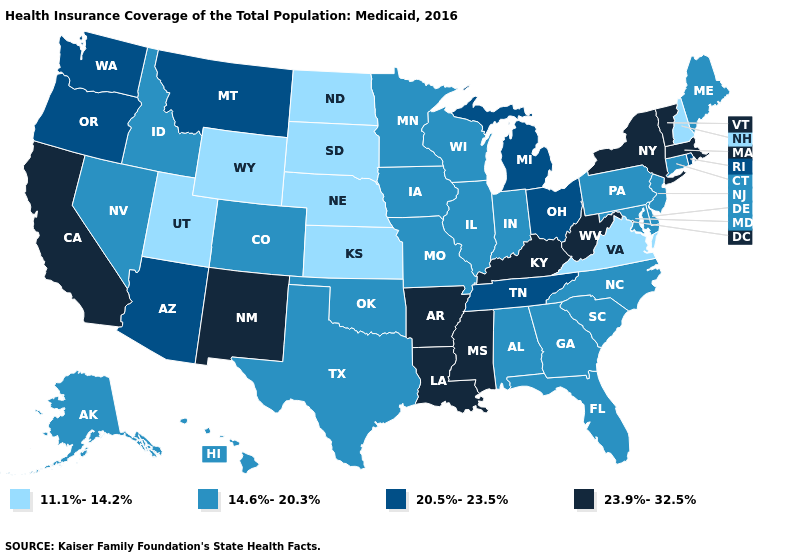What is the value of Utah?
Answer briefly. 11.1%-14.2%. What is the highest value in states that border Tennessee?
Write a very short answer. 23.9%-32.5%. Does Wisconsin have the lowest value in the USA?
Short answer required. No. How many symbols are there in the legend?
Quick response, please. 4. Which states have the highest value in the USA?
Short answer required. Arkansas, California, Kentucky, Louisiana, Massachusetts, Mississippi, New Mexico, New York, Vermont, West Virginia. Among the states that border Ohio , does Pennsylvania have the highest value?
Answer briefly. No. Name the states that have a value in the range 11.1%-14.2%?
Quick response, please. Kansas, Nebraska, New Hampshire, North Dakota, South Dakota, Utah, Virginia, Wyoming. Which states have the lowest value in the MidWest?
Give a very brief answer. Kansas, Nebraska, North Dakota, South Dakota. Name the states that have a value in the range 14.6%-20.3%?
Concise answer only. Alabama, Alaska, Colorado, Connecticut, Delaware, Florida, Georgia, Hawaii, Idaho, Illinois, Indiana, Iowa, Maine, Maryland, Minnesota, Missouri, Nevada, New Jersey, North Carolina, Oklahoma, Pennsylvania, South Carolina, Texas, Wisconsin. Does Maine have the highest value in the USA?
Be succinct. No. Name the states that have a value in the range 23.9%-32.5%?
Quick response, please. Arkansas, California, Kentucky, Louisiana, Massachusetts, Mississippi, New Mexico, New York, Vermont, West Virginia. Which states have the highest value in the USA?
Keep it brief. Arkansas, California, Kentucky, Louisiana, Massachusetts, Mississippi, New Mexico, New York, Vermont, West Virginia. Does the map have missing data?
Keep it brief. No. Does Kentucky have the highest value in the USA?
Quick response, please. Yes. Which states have the lowest value in the West?
Quick response, please. Utah, Wyoming. 